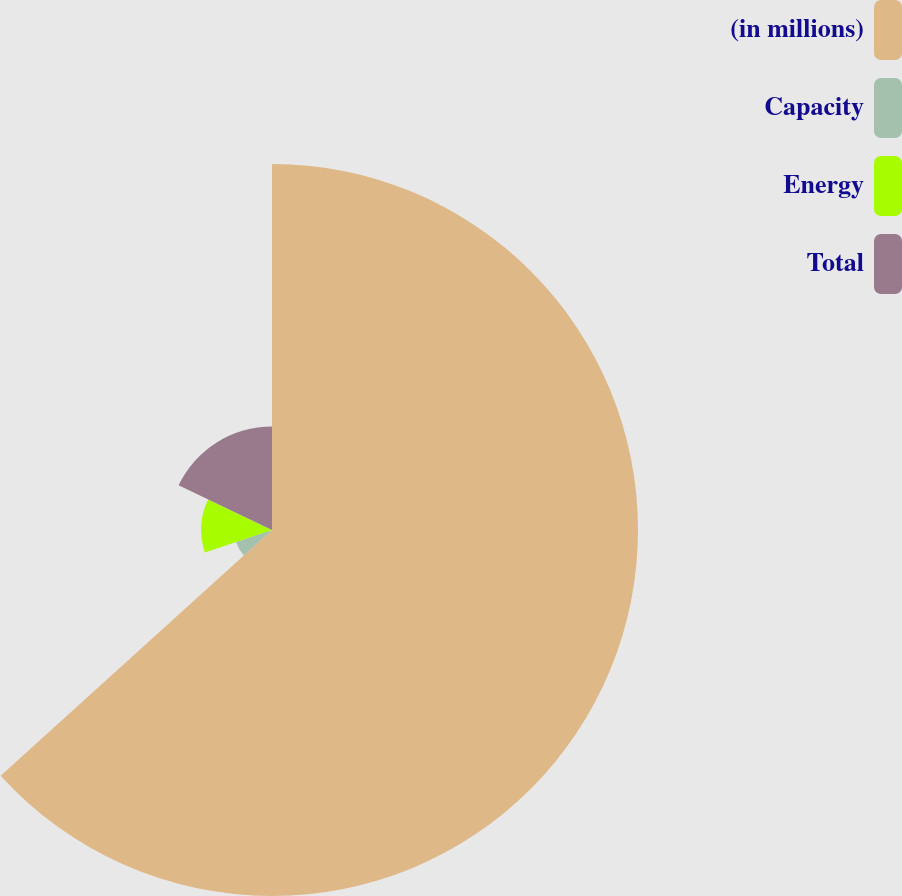<chart> <loc_0><loc_0><loc_500><loc_500><pie_chart><fcel>(in millions)<fcel>Capacity<fcel>Energy<fcel>Total<nl><fcel>63.29%<fcel>6.56%<fcel>12.24%<fcel>17.91%<nl></chart> 